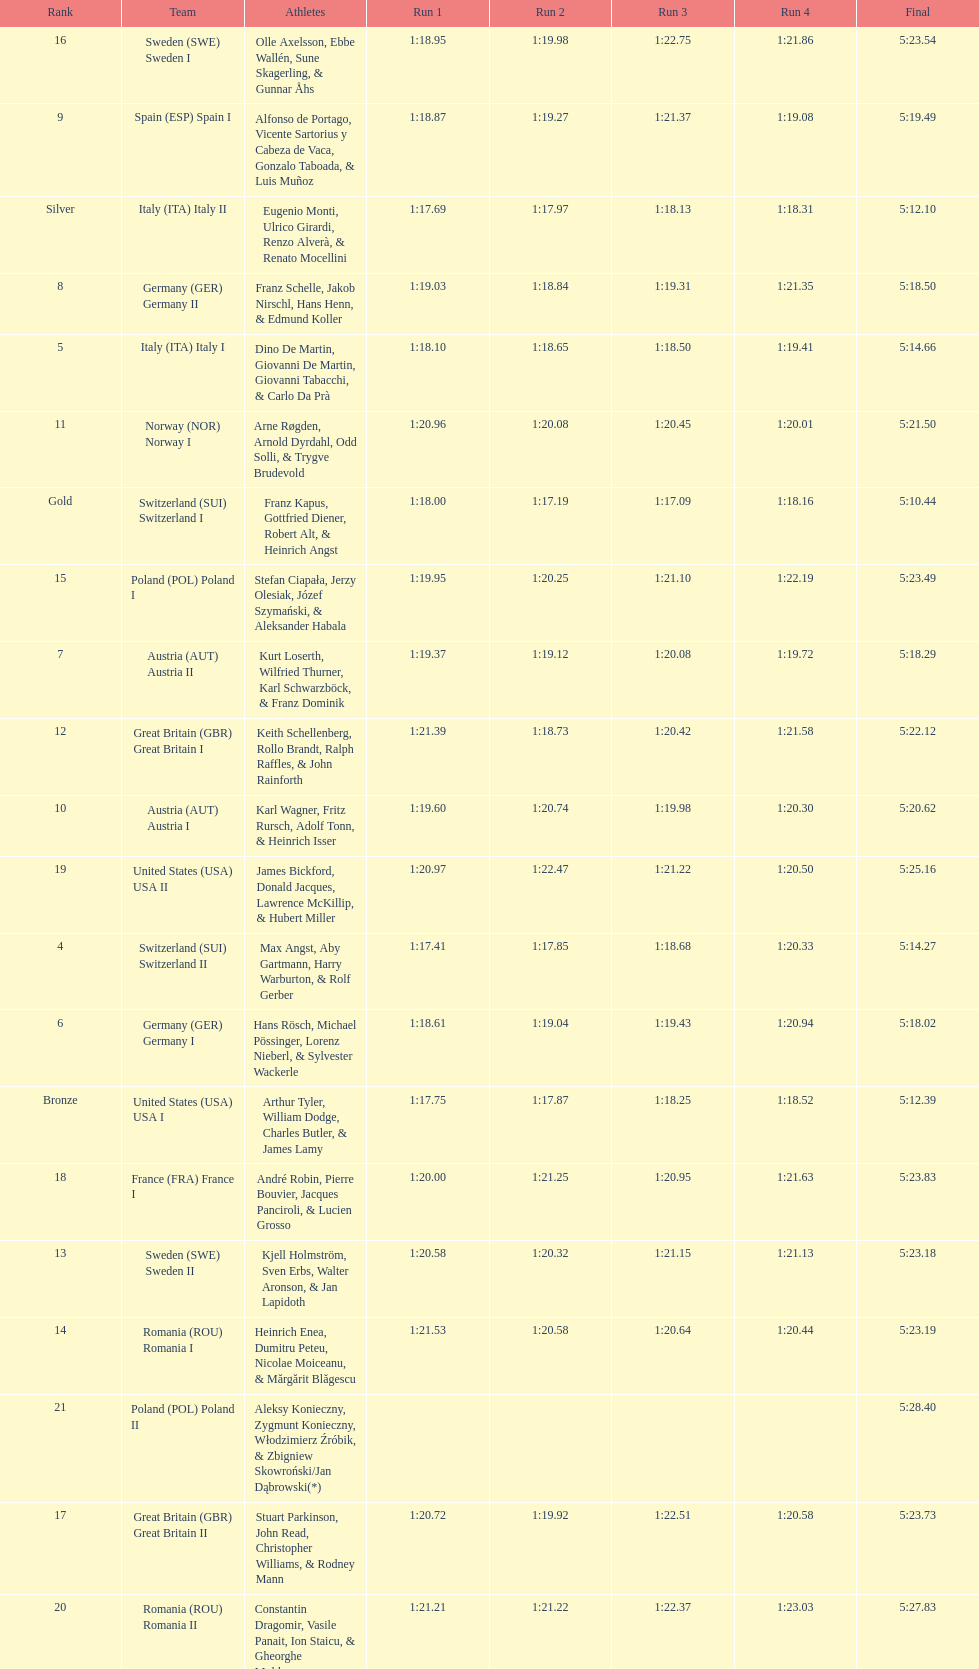Who is the previous team to italy (ita) italy ii? Switzerland (SUI) Switzerland I. 